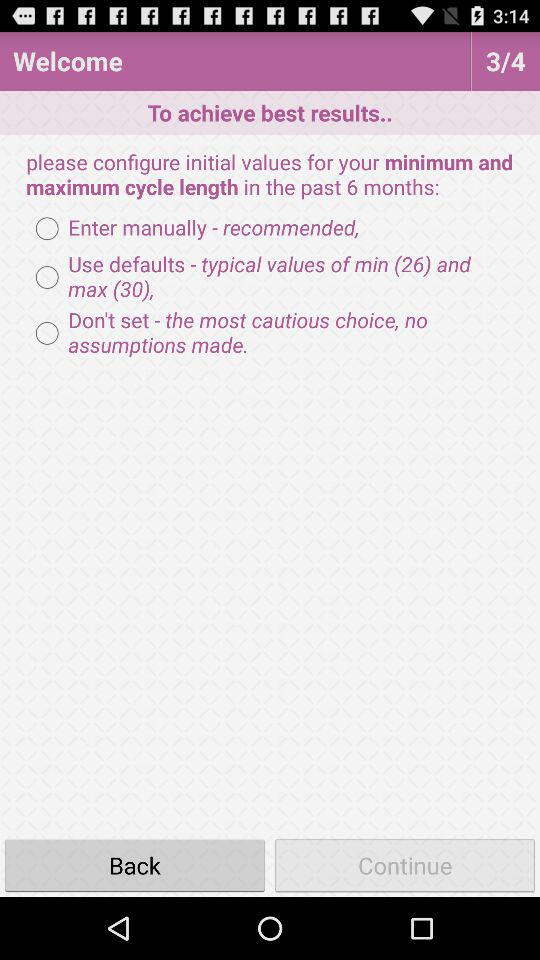Which page is the person on? The person is on page 3. 